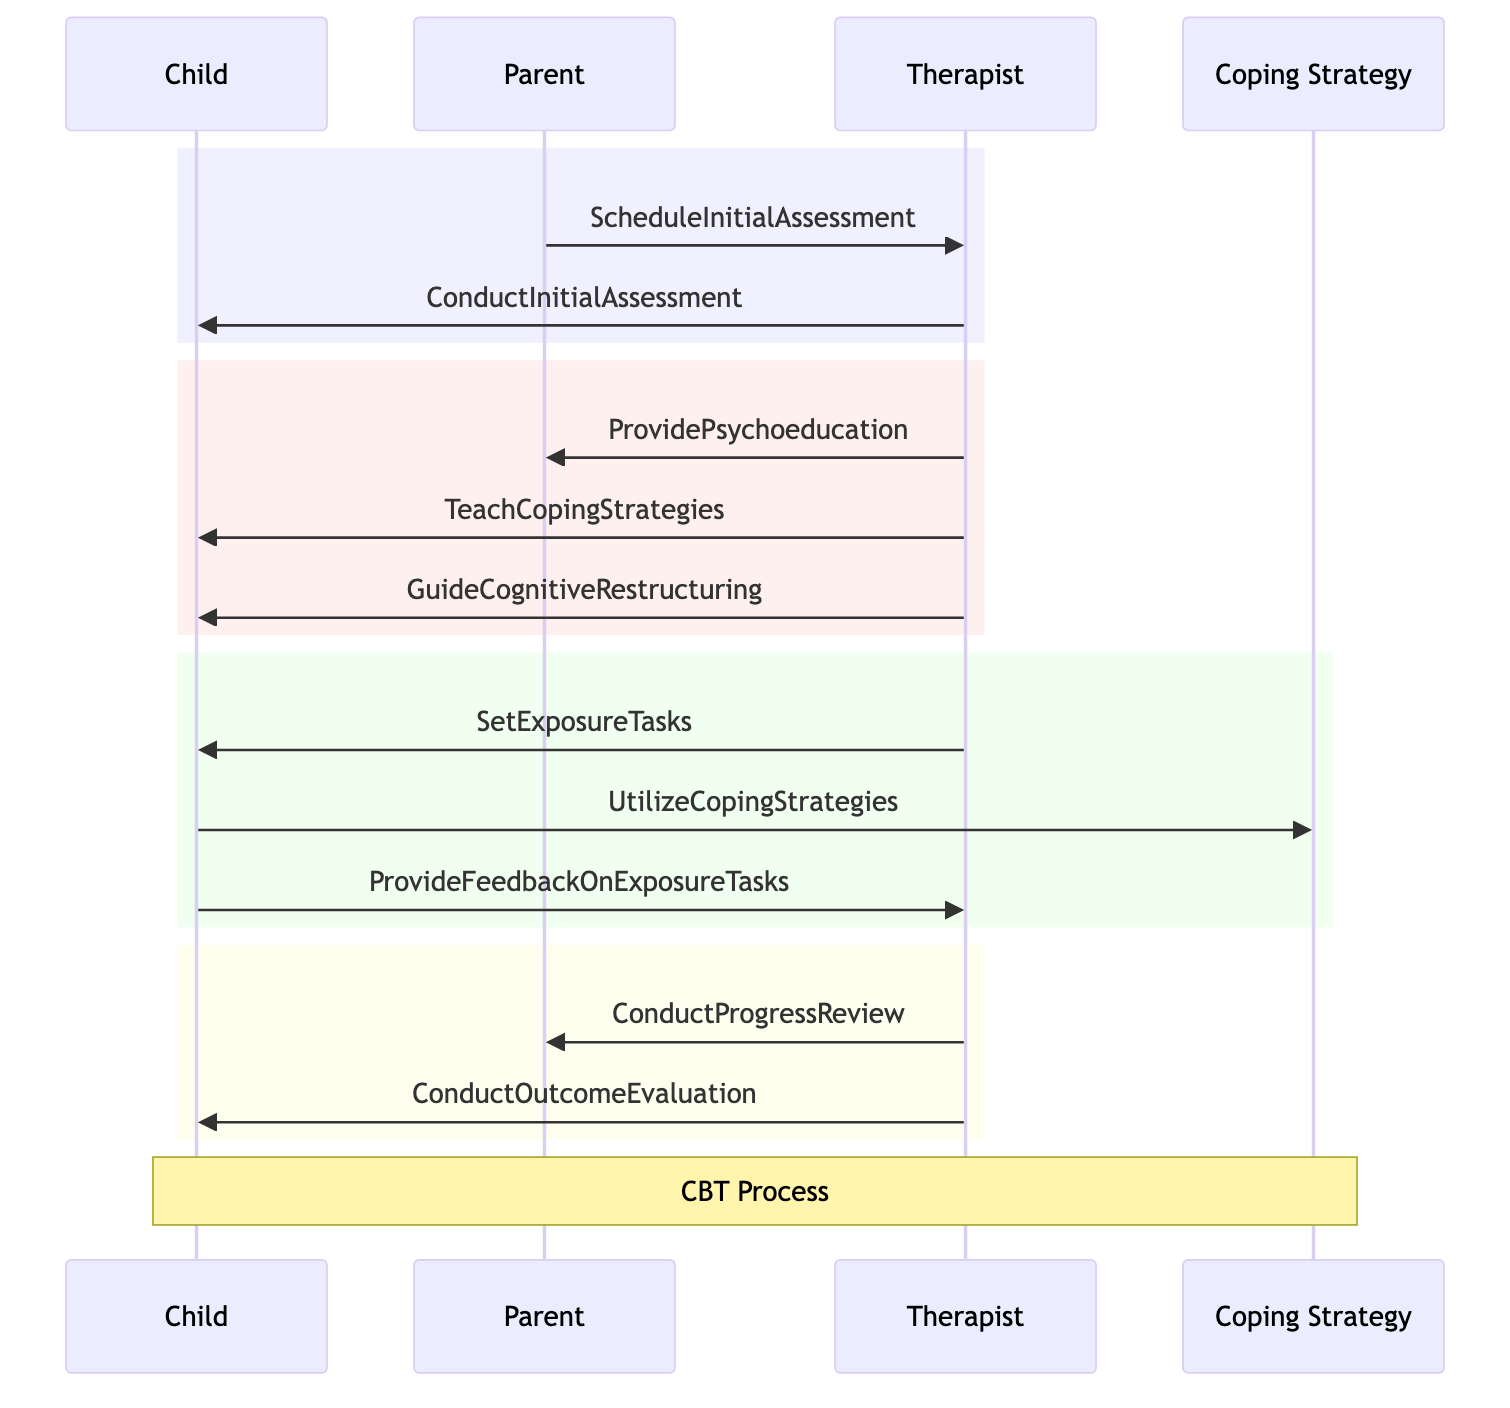What are the main actors in this diagram? The main actors in the diagram are identified at the start and include the Child, Parent, Therapist, and Coping Strategy. These actors are represented in the participant section of the sequence diagram.
Answer: Child, Parent, Therapist, Coping Strategy How many objects are present in the diagram? The objects in the diagram are listed, and they include InitialAssessment, Psychoeducation, CognitiveRestructuring, ExposureTasks, ProgressReview, and OutcomeEvaluation. Counting these, there are a total of six objects.
Answer: 6 Which message is sent from the Parent to the Therapist? The diagram shows a message flow from the Parent towards the Therapist labeled as ScheduleInitialAssessment. This message is the first interaction in the sequence.
Answer: ScheduleInitialAssessment What is the role of the Therapist after teaching Coping Strategies? After teaching Coping Strategies, the Therapist proceeds to set Exposure Tasks for the Child. This shows that the Therapist continues to guide the Child in the therapy process.
Answer: SetExposureTasks Which actor provides feedback on exposure tasks? The feedback on the exposure tasks comes from the Child to the Therapist. This is an important part of the therapy as it helps the Therapist assess the Child's progress and reactions.
Answer: Child What is the last interaction that occurs in the diagram? The final interaction that occurs in the diagram is labeled as ConductOutcomeEvaluation, which is directed from the Therapist to the Child. This step evaluates the effectiveness of the CBT process after the exposure tasks and progress reviews.
Answer: ConductOutcomeEvaluation How many steps does the Child take in the process? The Child engages in three specific steps throughout the diagram, which include ProvideFeedbackOnExposureTasks, UtilizeCopingStrategies, and ConductOutcomeEvaluation. Each of these steps indicates the Child's active role in the therapy.
Answer: 3 What happens after ConductInitialAssessment? After the ConductInitialAssessment, the Therapist provides Psychoeducation to the Parent and teaches Coping Strategies to the Child, as indicated in the next steps of the interaction flow.
Answer: ProvidePsychoeducation, TeachCopingStrategies 